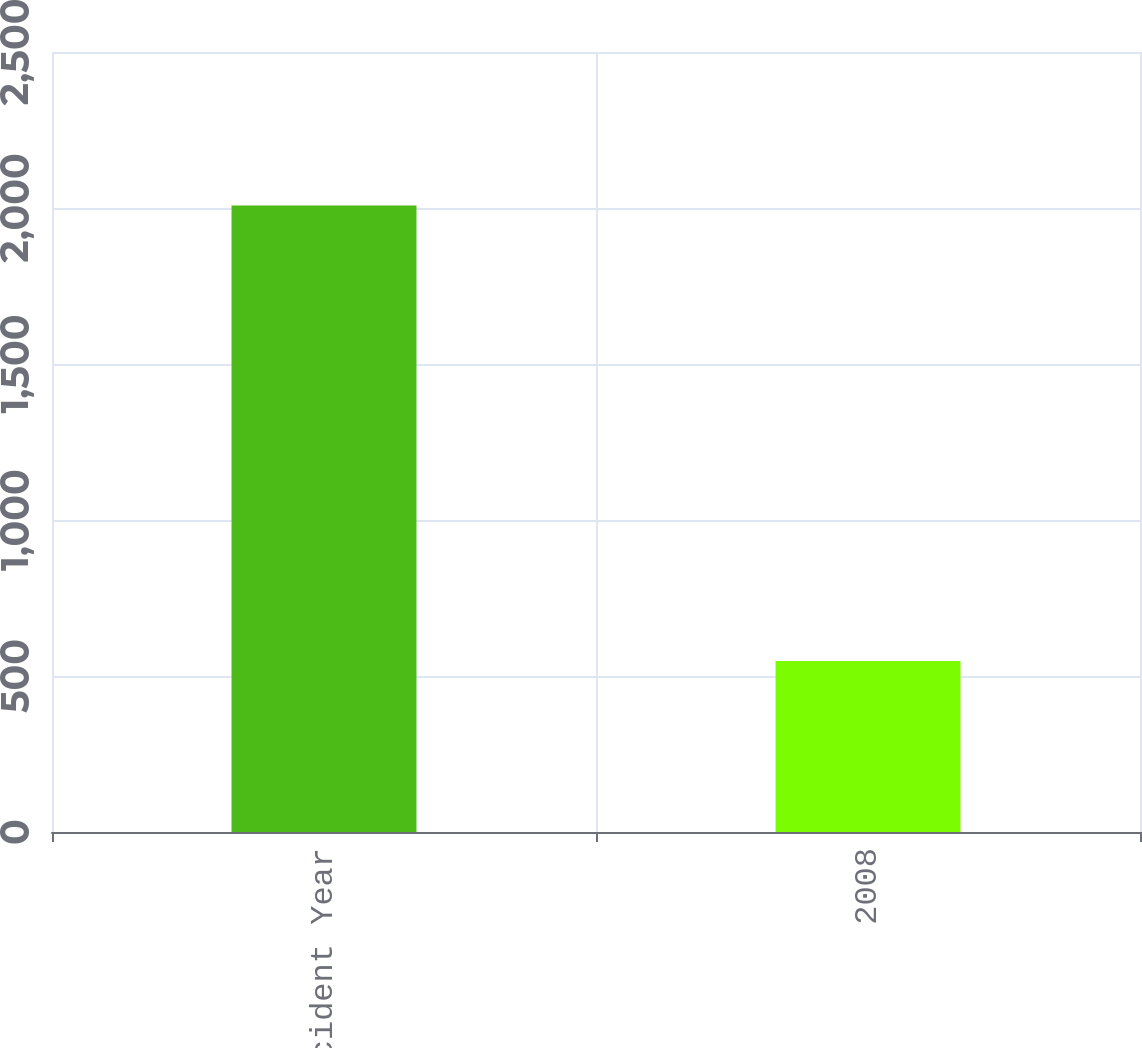Convert chart to OTSL. <chart><loc_0><loc_0><loc_500><loc_500><bar_chart><fcel>Accident Year<fcel>2008<nl><fcel>2008<fcel>548<nl></chart> 